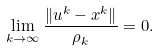<formula> <loc_0><loc_0><loc_500><loc_500>\lim _ { k \to \infty } \frac { \| u ^ { k } - x ^ { k } \| } { \rho _ { k } } = 0 .</formula> 